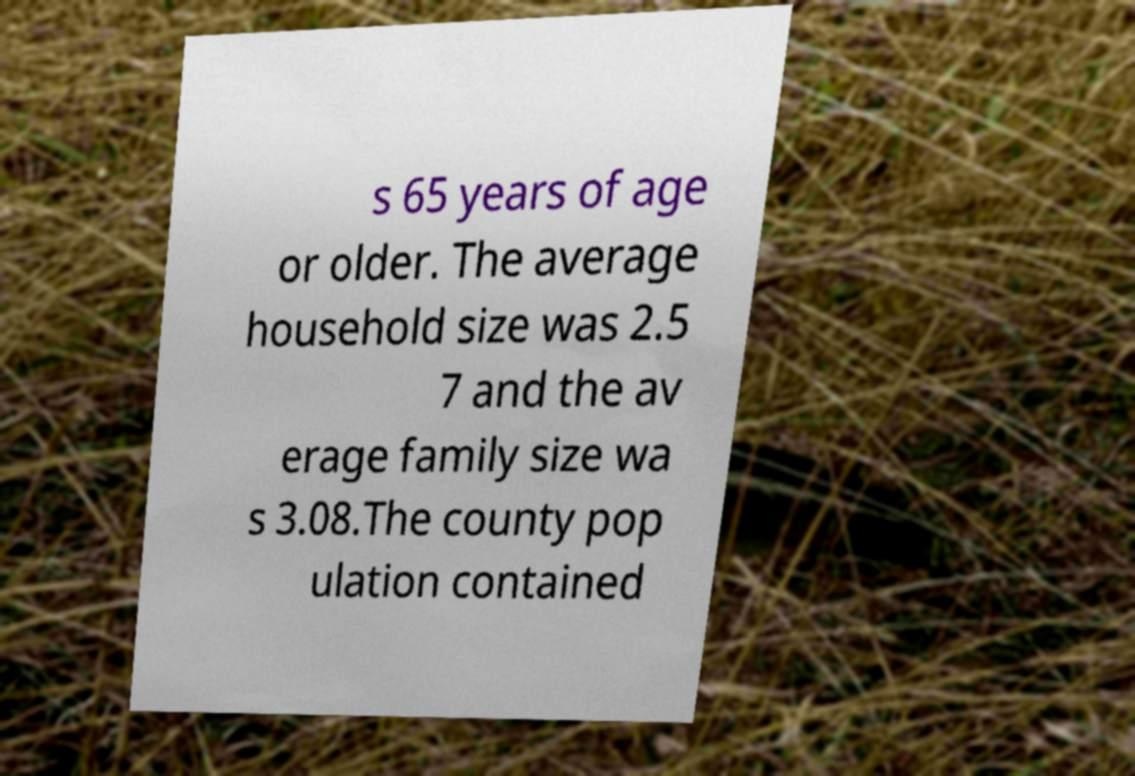Please identify and transcribe the text found in this image. s 65 years of age or older. The average household size was 2.5 7 and the av erage family size wa s 3.08.The county pop ulation contained 